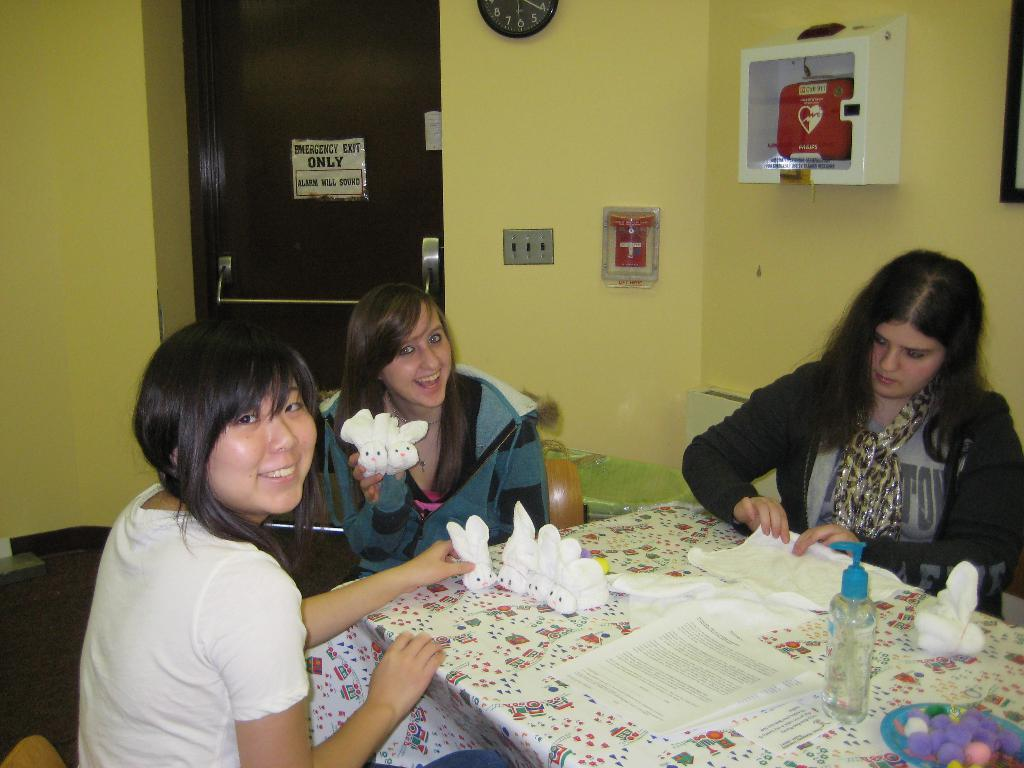What are the people in the image doing? The people in the image are sitting on chairs. What objects can be seen on the table in the image? There are papers and a hand sanitizer on the table in the image. What type of flower is sitting on the chair next to the person in the image? There is no flower present in the image; only people sitting on chairs, papers, and a hand sanitizer on the table are visible. 